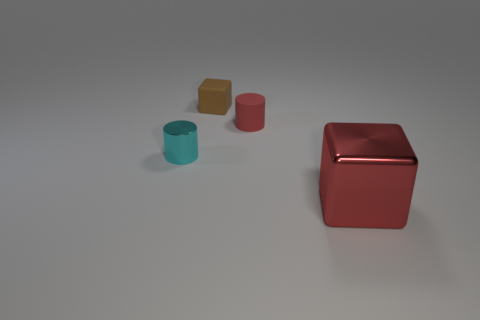Which objects in the image appear to be the closest to each other? The two smaller cylinders appear to be the closest to each other. 